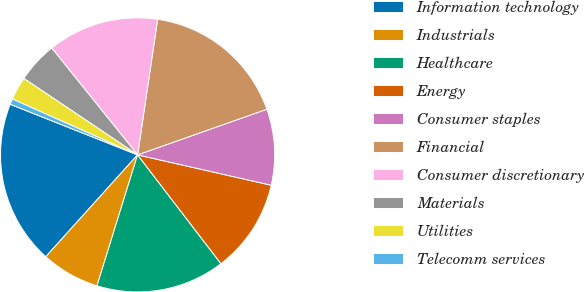Convert chart to OTSL. <chart><loc_0><loc_0><loc_500><loc_500><pie_chart><fcel>Information technology<fcel>Industrials<fcel>Healthcare<fcel>Energy<fcel>Consumer staples<fcel>Financial<fcel>Consumer discretionary<fcel>Materials<fcel>Utilities<fcel>Telecomm services<nl><fcel>19.34%<fcel>6.89%<fcel>15.19%<fcel>11.04%<fcel>8.96%<fcel>17.26%<fcel>13.11%<fcel>4.81%<fcel>2.74%<fcel>0.66%<nl></chart> 